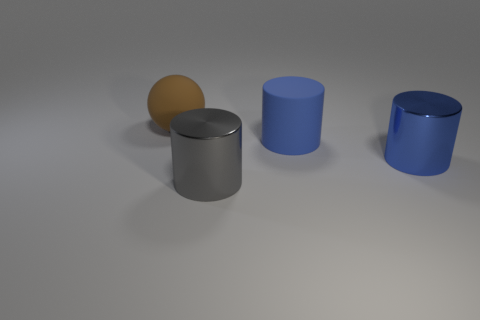There is another blue cylinder that is the same size as the rubber cylinder; what is it made of? Based on the image, the other blue cylinder appears to be made of a smooth, reflective material, likely metal, similar in texture and sheen to materials like aluminum or steel. 